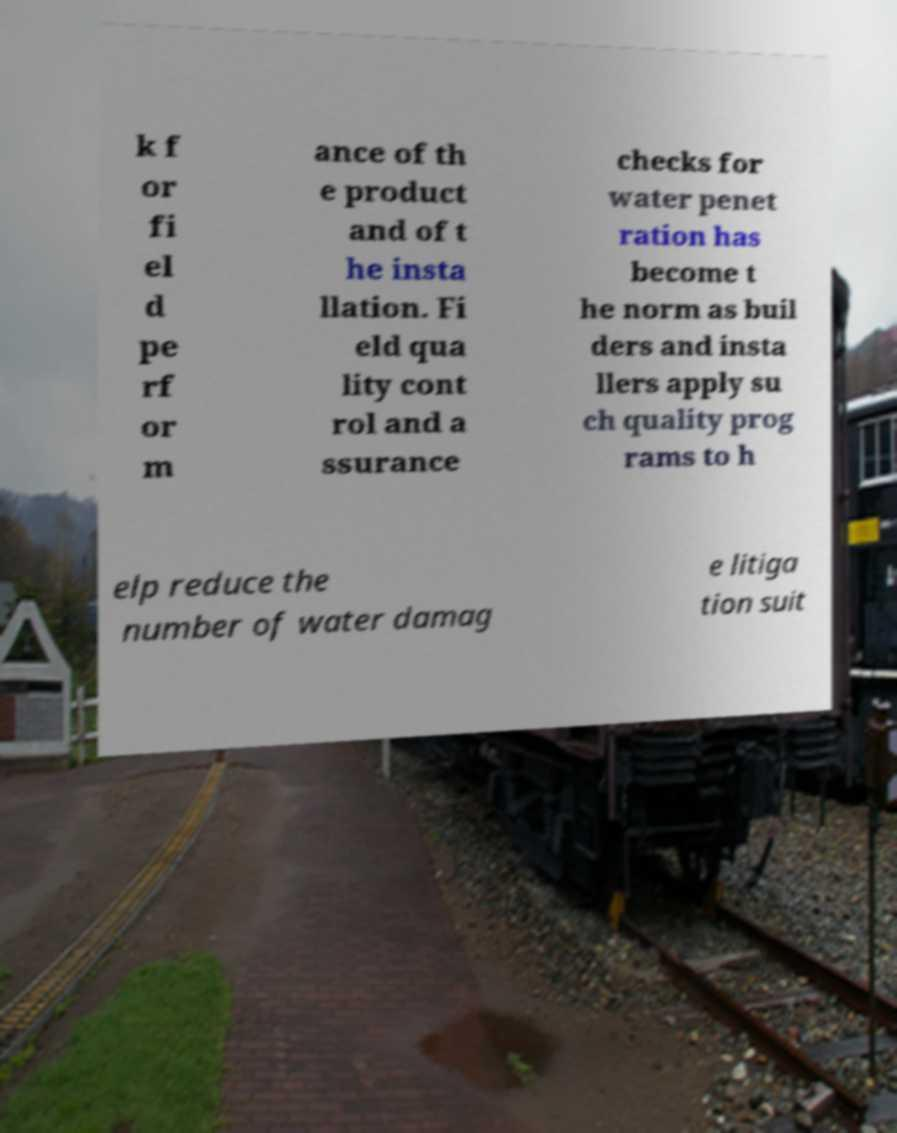For documentation purposes, I need the text within this image transcribed. Could you provide that? k f or fi el d pe rf or m ance of th e product and of t he insta llation. Fi eld qua lity cont rol and a ssurance checks for water penet ration has become t he norm as buil ders and insta llers apply su ch quality prog rams to h elp reduce the number of water damag e litiga tion suit 